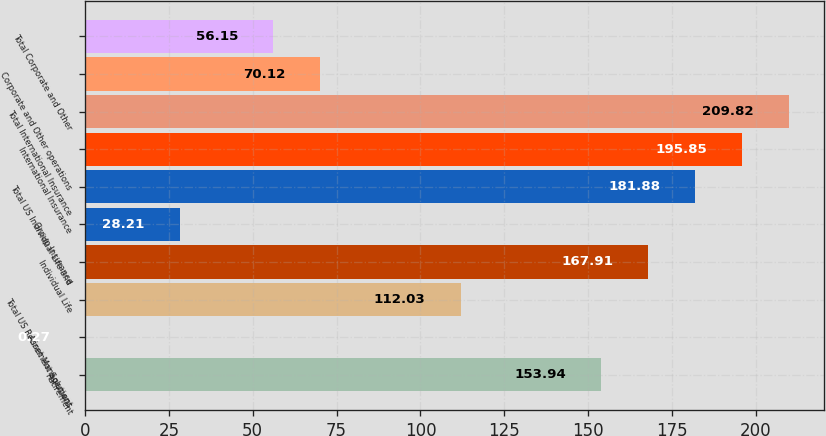Convert chart. <chart><loc_0><loc_0><loc_500><loc_500><bar_chart><fcel>Retirement<fcel>Asset Management<fcel>Total US Retirement Solutions<fcel>Individual Life<fcel>Group Insurance<fcel>Total US Individual Life and<fcel>International Insurance<fcel>Total International Insurance<fcel>Corporate and Other operations<fcel>Total Corporate and Other<nl><fcel>153.94<fcel>0.27<fcel>112.03<fcel>167.91<fcel>28.21<fcel>181.88<fcel>195.85<fcel>209.82<fcel>70.12<fcel>56.15<nl></chart> 